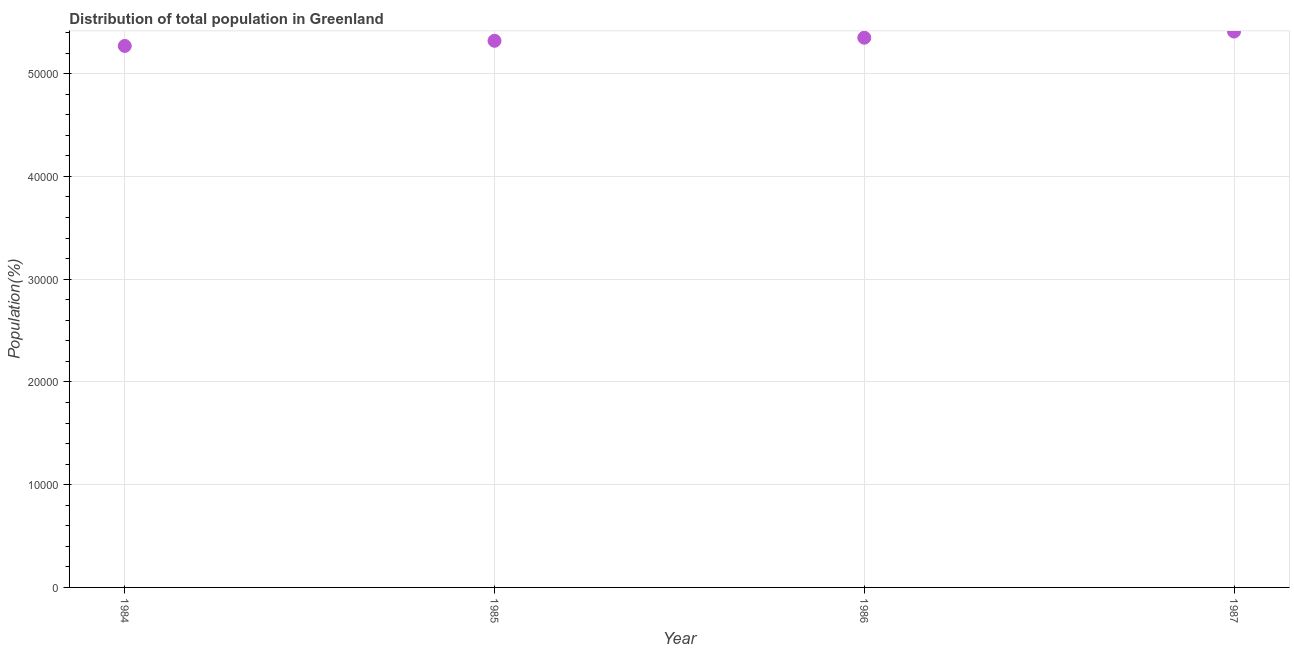What is the population in 1987?
Keep it short and to the point. 5.41e+04. Across all years, what is the maximum population?
Give a very brief answer. 5.41e+04. Across all years, what is the minimum population?
Offer a terse response. 5.27e+04. In which year was the population minimum?
Your answer should be compact. 1984. What is the sum of the population?
Your answer should be compact. 2.14e+05. What is the difference between the population in 1986 and 1987?
Your response must be concise. -600. What is the average population per year?
Provide a short and direct response. 5.34e+04. What is the median population?
Keep it short and to the point. 5.34e+04. What is the ratio of the population in 1986 to that in 1987?
Offer a very short reply. 0.99. What is the difference between the highest and the second highest population?
Give a very brief answer. 600. Is the sum of the population in 1984 and 1985 greater than the maximum population across all years?
Give a very brief answer. Yes. What is the difference between the highest and the lowest population?
Your answer should be compact. 1400. How many years are there in the graph?
Ensure brevity in your answer.  4. What is the difference between two consecutive major ticks on the Y-axis?
Ensure brevity in your answer.  10000. Does the graph contain any zero values?
Make the answer very short. No. What is the title of the graph?
Your response must be concise. Distribution of total population in Greenland . What is the label or title of the Y-axis?
Your response must be concise. Population(%). What is the Population(%) in 1984?
Give a very brief answer. 5.27e+04. What is the Population(%) in 1985?
Keep it short and to the point. 5.32e+04. What is the Population(%) in 1986?
Your answer should be very brief. 5.35e+04. What is the Population(%) in 1987?
Offer a terse response. 5.41e+04. What is the difference between the Population(%) in 1984 and 1985?
Offer a very short reply. -500. What is the difference between the Population(%) in 1984 and 1986?
Offer a terse response. -800. What is the difference between the Population(%) in 1984 and 1987?
Your answer should be compact. -1400. What is the difference between the Population(%) in 1985 and 1986?
Your response must be concise. -300. What is the difference between the Population(%) in 1985 and 1987?
Your answer should be compact. -900. What is the difference between the Population(%) in 1986 and 1987?
Offer a terse response. -600. What is the ratio of the Population(%) in 1984 to that in 1985?
Provide a succinct answer. 0.99. What is the ratio of the Population(%) in 1985 to that in 1987?
Offer a very short reply. 0.98. 